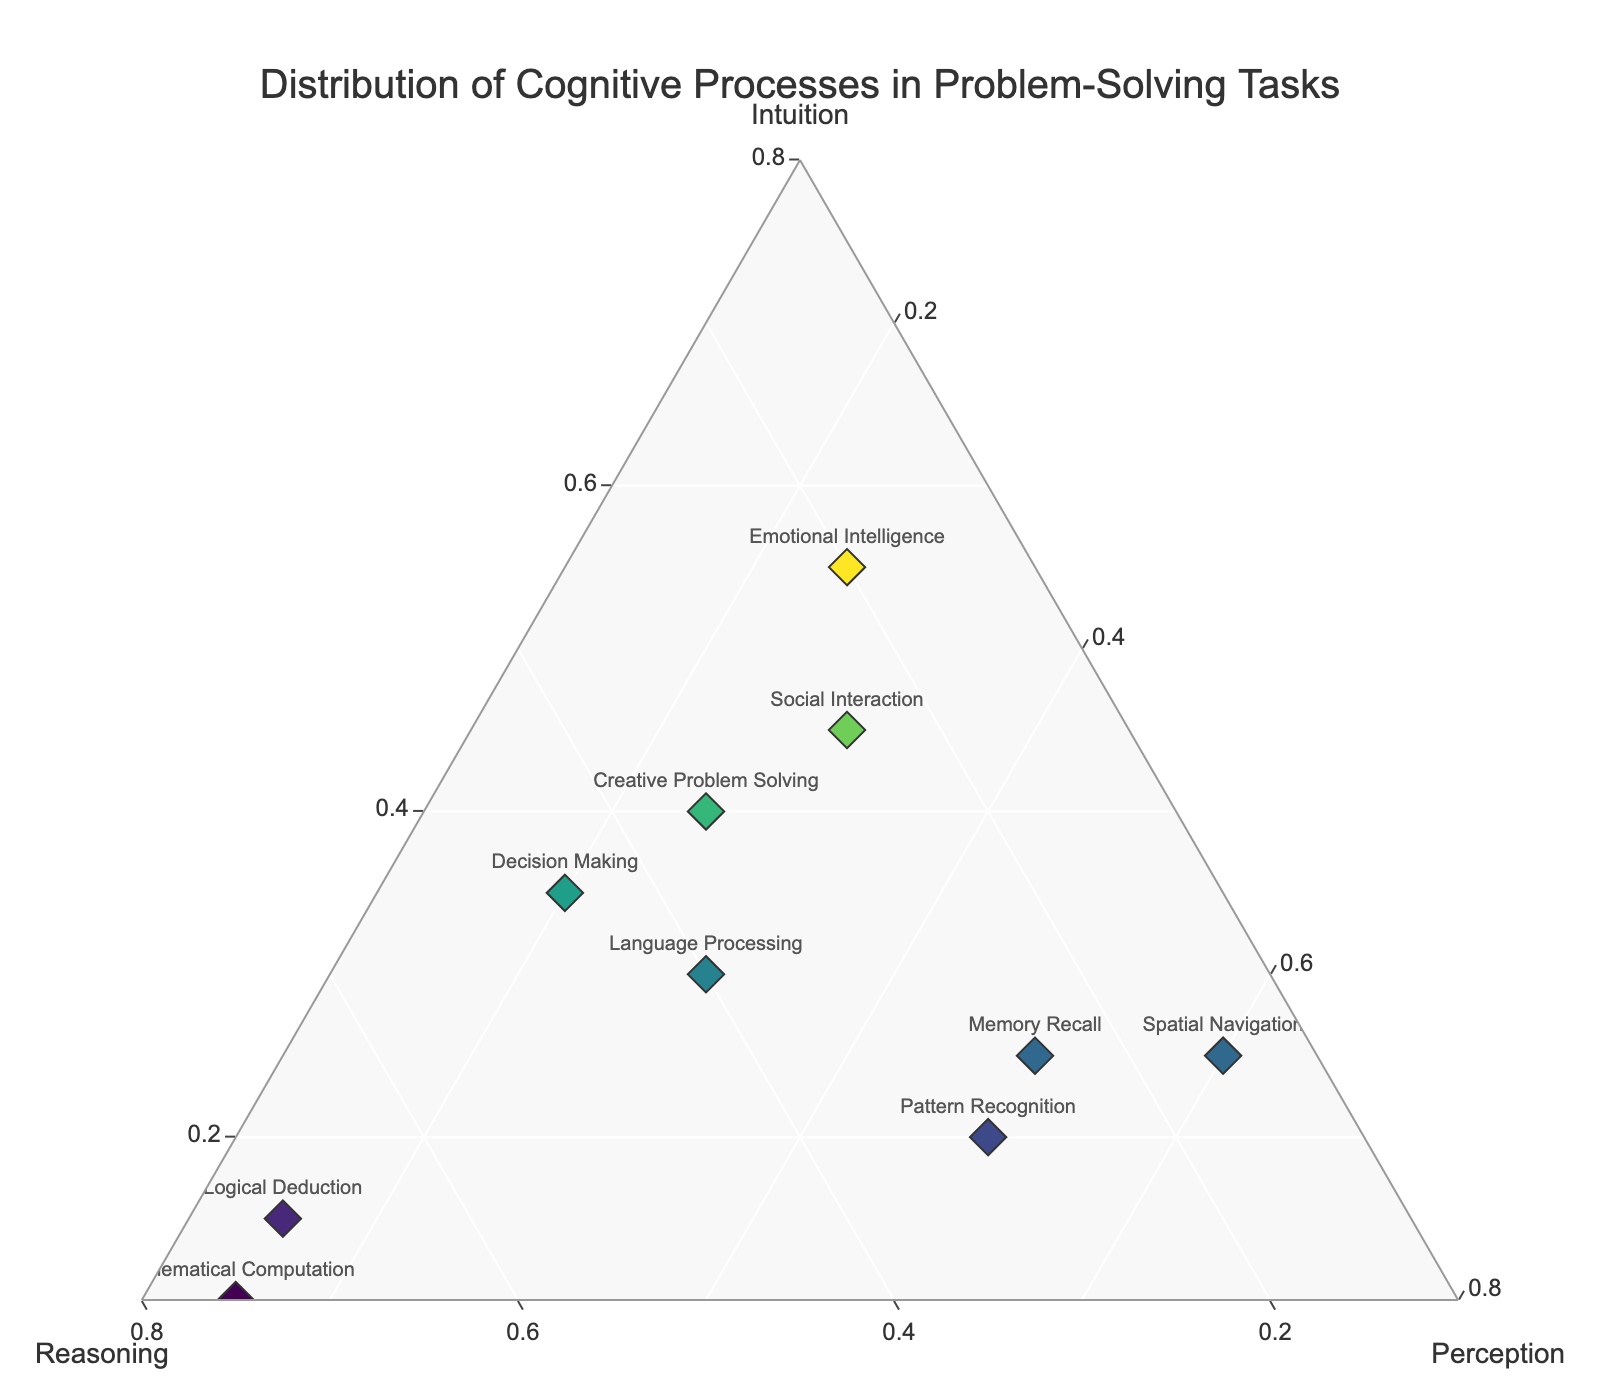What is the title of the plot? The title is usually found at the top of the plot and provides an overview of what the figure represents.
Answer: Distribution of Cognitive Processes in Problem-Solving Tasks What are the three axes representing? In a ternary plot, each vertex or axis represents one of the categories. Here, they are labeled as Intuition, Reasoning, and Perception.
Answer: Intuition, Reasoning, and Perception Which task has the highest proportion of intuition? By locating the tasks represented on the plot closer to the 'Intuition' axis, we see that 'Emotional Intelligence' is the closest to Intuition.
Answer: Emotional Intelligence Which task has balanced proportions across intuition, reasoning, and perception? A balanced task would be located near the center of the plot. 'Language Processing' appears centrally located in the plot.
Answer: Language Processing What is the combined proportion of intuition and perception for 'Social Interaction'? To find this, sum the intuition proportion (0.45) and perception proportion (0.30) for 'Social Interaction'.
Answer: 0.75 Which task requires the most perception? Locate the task represented by points closest to the 'Perception' axis. 'Spatial Navigation' and 'Memory Recall' show the highest perception, but 'Spatial Navigation' is slightly closer.
Answer: Spatial Navigation Is there any task with less than 20% reasoning? Check for tasks with a reasoning proportion below 0.20. Both 'Emotional Intelligence' and 'Spatial Navigation' meet this criterion.
Answer: Yes Which tasks are more reliant on reasoning than intuition? Compare the proportions where reasoning is greater than intuition. This is true for 'Logical Deduction', 'Pattern Recognition', 'Decision Making', 'Language Processing', and 'Mathematical Computation'.
Answer: Logical Deduction, Pattern Recognition, Decision Making, Language Processing, Mathematical Computation Which task has the least proportion of perception? Locate the task represented by points furthest from the 'Perception' axis. 'Mathematical Computation' and 'Logical Deduction' both have the lowest perception at 0.15.
Answer: Mathematical Computation, Logical Deduction What is the difference in the proportion of reasoning between 'Mathematical Computation' and 'Creative Problem Solving'? Subtract the reasoning proportion of 'Creative Problem Solving' (0.35) from that of 'Mathematical Computation' (0.75).
Answer: 0.40 